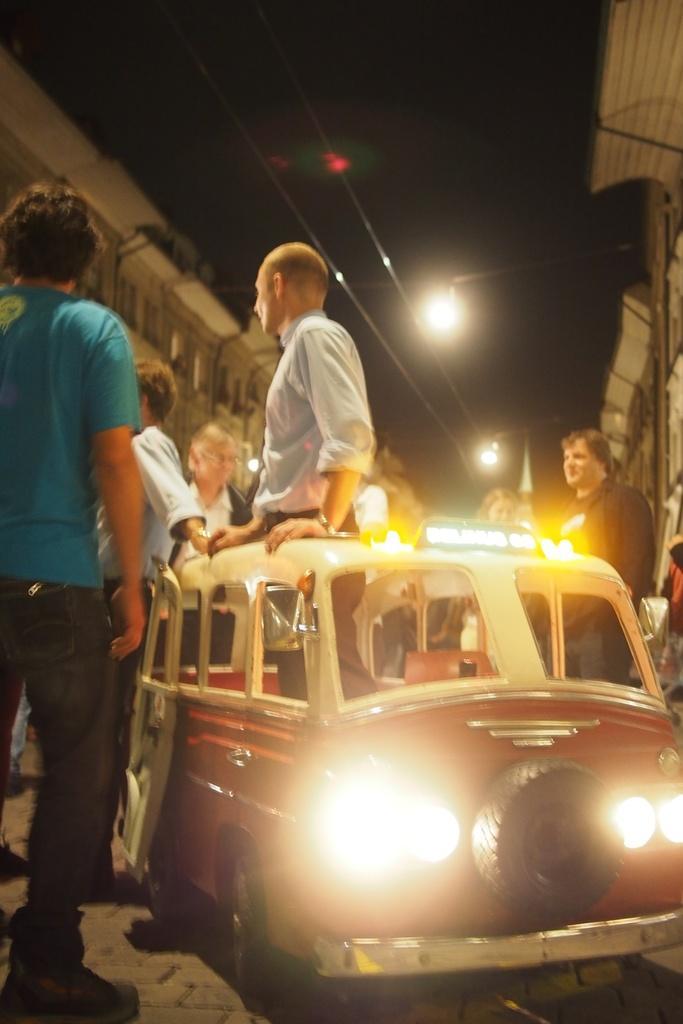Please provide a concise description of this image. In front of the image there is a person standing in a car, around the person there are few other people standing, in the background of the image there are buildings, at the top of the image there are cables and lamps. 